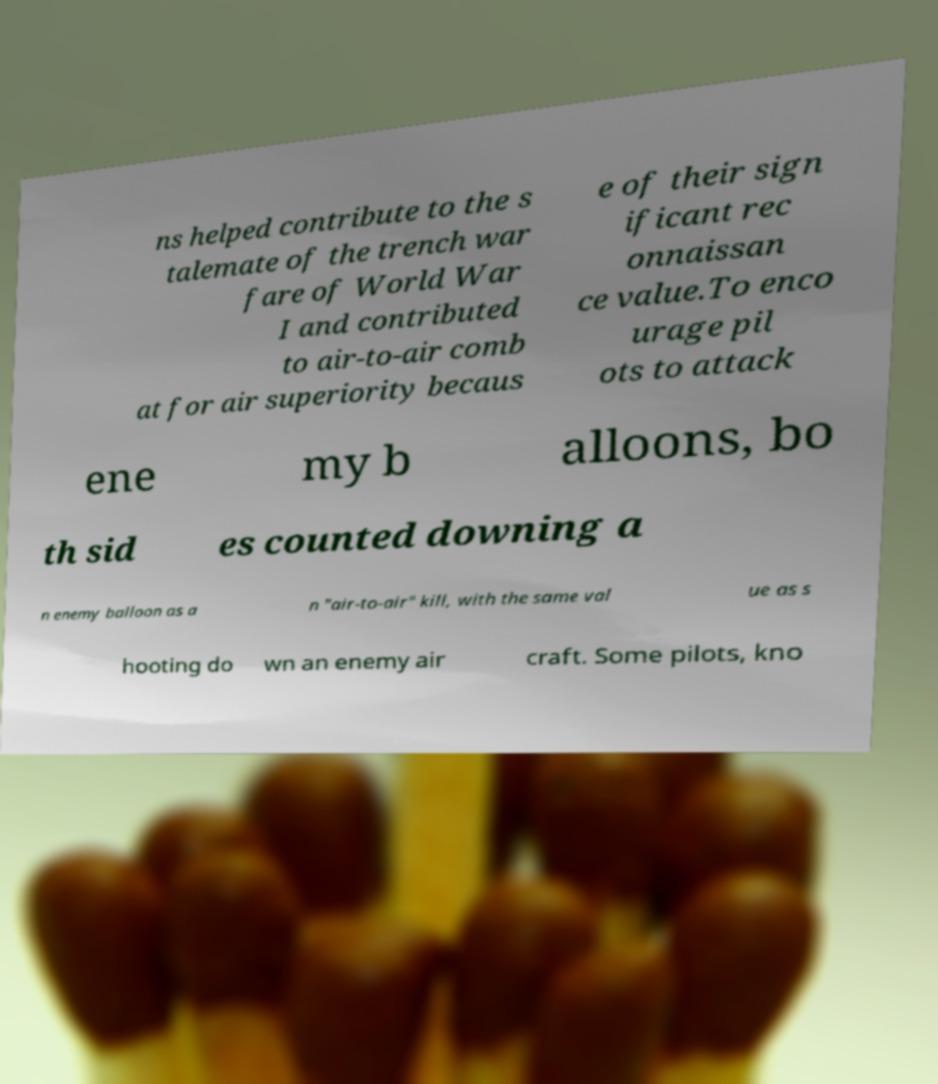There's text embedded in this image that I need extracted. Can you transcribe it verbatim? ns helped contribute to the s talemate of the trench war fare of World War I and contributed to air-to-air comb at for air superiority becaus e of their sign ificant rec onnaissan ce value.To enco urage pil ots to attack ene my b alloons, bo th sid es counted downing a n enemy balloon as a n "air-to-air" kill, with the same val ue as s hooting do wn an enemy air craft. Some pilots, kno 